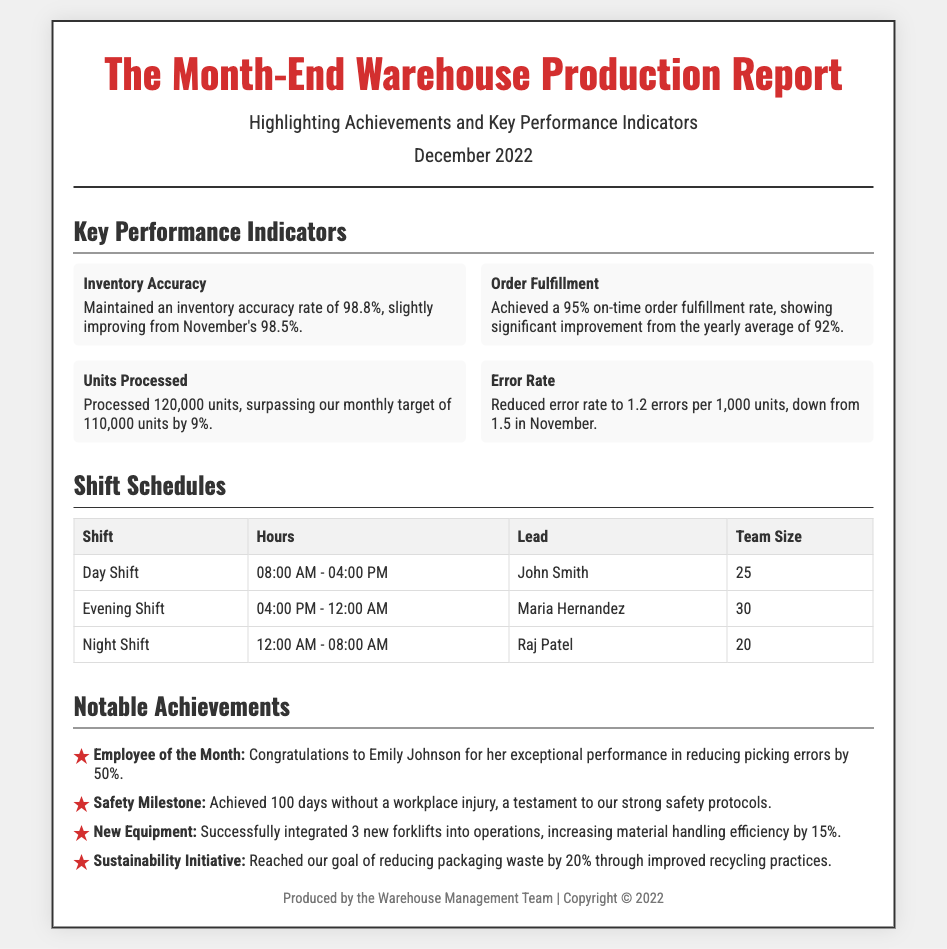What was the inventory accuracy rate for December 2022? The inventory accuracy rate for December 2022 was maintained at 98.8%.
Answer: 98.8% How many units were processed in December 2022? The document states that 120,000 units were processed in December 2022.
Answer: 120,000 Who led the evening shift? The evening shift was led by Maria Hernandez.
Answer: Maria Hernandez What is the on-time order fulfillment rate achieved in December? The on-time order fulfillment rate achieved in December was 95%.
Answer: 95% What significant improvement was made in the error rate? The document notes the error rate was reduced to 1.2 errors per 1,000 units, improving from 1.5 in November.
Answer: 1.2 errors per 1,000 units Who was named Employee of the Month? The Employee of the Month for December was Emily Johnson.
Answer: Emily Johnson How many days without a workplace injury did the warehouse achieve? The warehouse achieved 100 days without a workplace injury.
Answer: 100 days What improvement was noted with the new equipment? The integration of new equipment increased material handling efficiency by 15%.
Answer: 15% What was the goal achieved regarding packaging waste? The warehouse reached a goal of reducing packaging waste by 20%.
Answer: 20% 